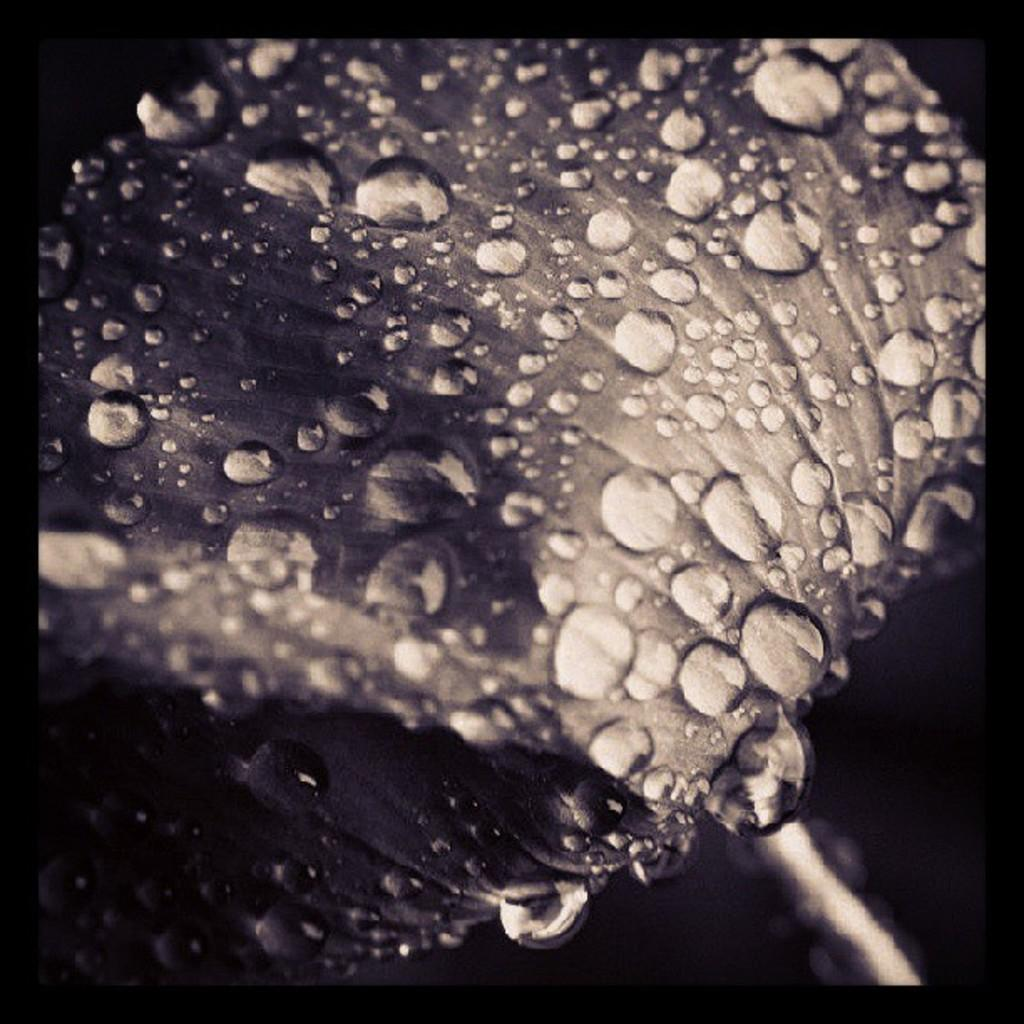What is the color scheme of the image? The image is black and white. What is the main subject of the image? There is a flower in the middle of the image. Can you describe the flower in the image? Droplets of water are visible on the flower. What type of object might the image be a part of? The image might be a photo frame. Reasoning: Let's think step by step by step in order to produce the conversation. We start by identifying the color scheme of the image, which is black and white. Then, we focus on the main subject of the image, which is a flower. We describe the flower in detail, mentioning the droplets of water visible on it. Finally, we speculate about the object that the image might be a part of, suggesting that it could be a photo frame. Absurd Question/Answer: What type of pancake is being served on the flower in the image? There is no pancake present in the image; it features a black and white flower with droplets of water. What is the writer doing in the image? There is no writer present in the image; it features a black and white flower with droplets of water. 